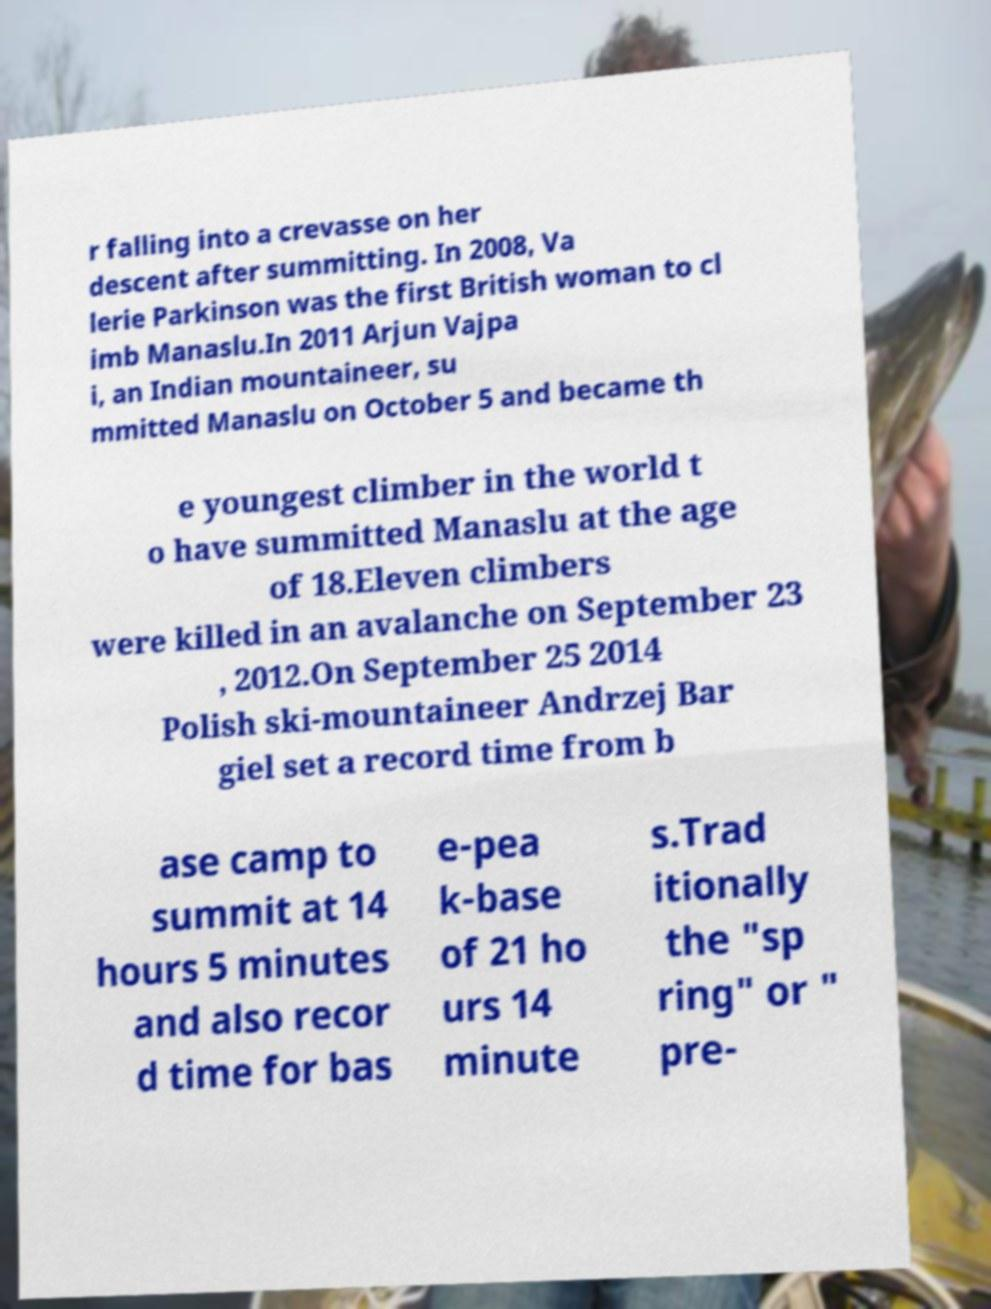There's text embedded in this image that I need extracted. Can you transcribe it verbatim? r falling into a crevasse on her descent after summitting. In 2008, Va lerie Parkinson was the first British woman to cl imb Manaslu.In 2011 Arjun Vajpa i, an Indian mountaineer, su mmitted Manaslu on October 5 and became th e youngest climber in the world t o have summitted Manaslu at the age of 18.Eleven climbers were killed in an avalanche on September 23 , 2012.On September 25 2014 Polish ski-mountaineer Andrzej Bar giel set a record time from b ase camp to summit at 14 hours 5 minutes and also recor d time for bas e-pea k-base of 21 ho urs 14 minute s.Trad itionally the "sp ring" or " pre- 